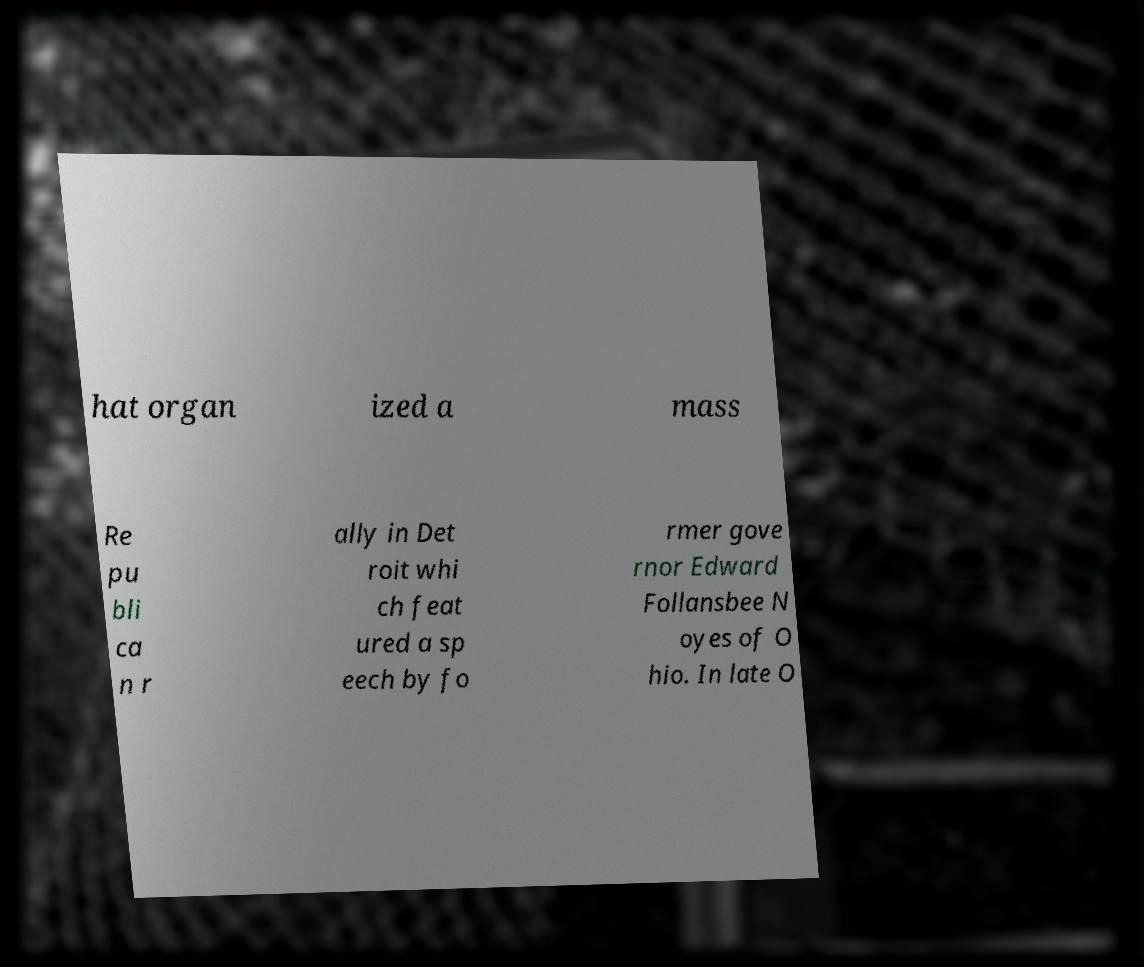I need the written content from this picture converted into text. Can you do that? hat organ ized a mass Re pu bli ca n r ally in Det roit whi ch feat ured a sp eech by fo rmer gove rnor Edward Follansbee N oyes of O hio. In late O 